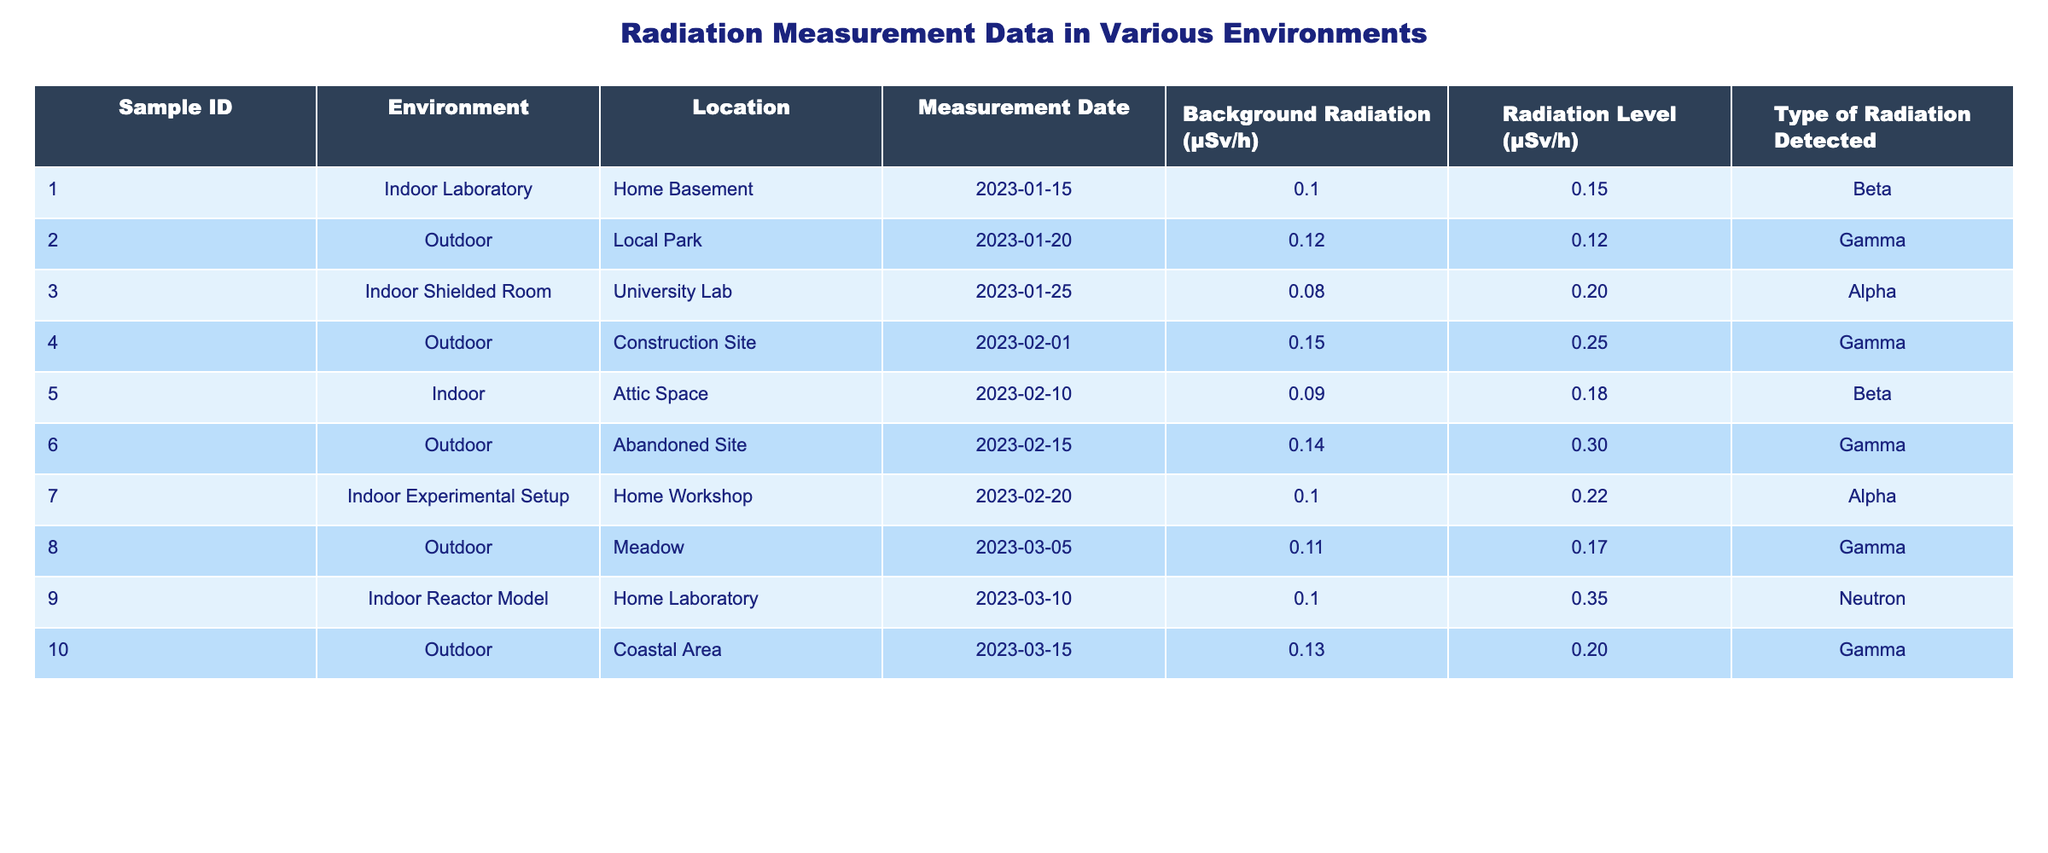What is the radiation level measured in the Indoor Laboratory? The table indicates that for Sample ID 1 in the Indoor Laboratory, the Radiation Level is 0.15 μSv/h.
Answer: 0.15 μSv/h Which environment has the highest measured radiation level? Looking at the Radiation Level column, the highest value is 0.35 μSv/h, which corresponds to the Indoor Reactor Model (Sample ID 9).
Answer: Indoor Reactor Model Is there a measurement where the background radiation is equal to the radiation level? By examining the table, Sample ID 2 (Outdoor at Local Park) shows a Background Radiation of 0.12 μSv/h, which is equal to its Radiation Level of 0.12 μSv/h.
Answer: Yes What is the average background radiation level across all samples? To find the average, sum the background radiation values (0.10 + 0.12 + 0.08 + 0.15 + 0.09 + 0.14 + 0.10 + 0.11 + 0.10 + 0.13 = 1.20), which has 10 samples, so the average is 1.20 / 10 = 0.12 μSv/h.
Answer: 0.12 μSv/h Which type of radiation was detected in the highest reading? Reviewing the radiation levels, the Indoor Reactor Model (Sample ID 9) with a measurement of 0.35 μSv/h shows Neutron radiation, which is the highest detected.
Answer: Neutron How many measurements were taken in outdoor environments? From the table, Samples 2, 4, 6, 8, and 10 are all in outdoor settings, totaling 5 measurements.
Answer: 5 Is the radiation level in the Attic Space greater than the background radiation? For Sample ID 5, the Background Radiation is 0.09 μSv/h while the Radiation Level is 0.18 μSv/h, thus the radiation level is greater than background.
Answer: Yes What is the difference between the highest and lowest radiation levels detected? The highest detected radiation level is 0.35 μSv/h (Indoor Reactor Model) and the lowest level is 0.12 μSv/h (Outdoor at Local Park). The difference is 0.35 - 0.12 = 0.23 μSv/h.
Answer: 0.23 μSv/h 